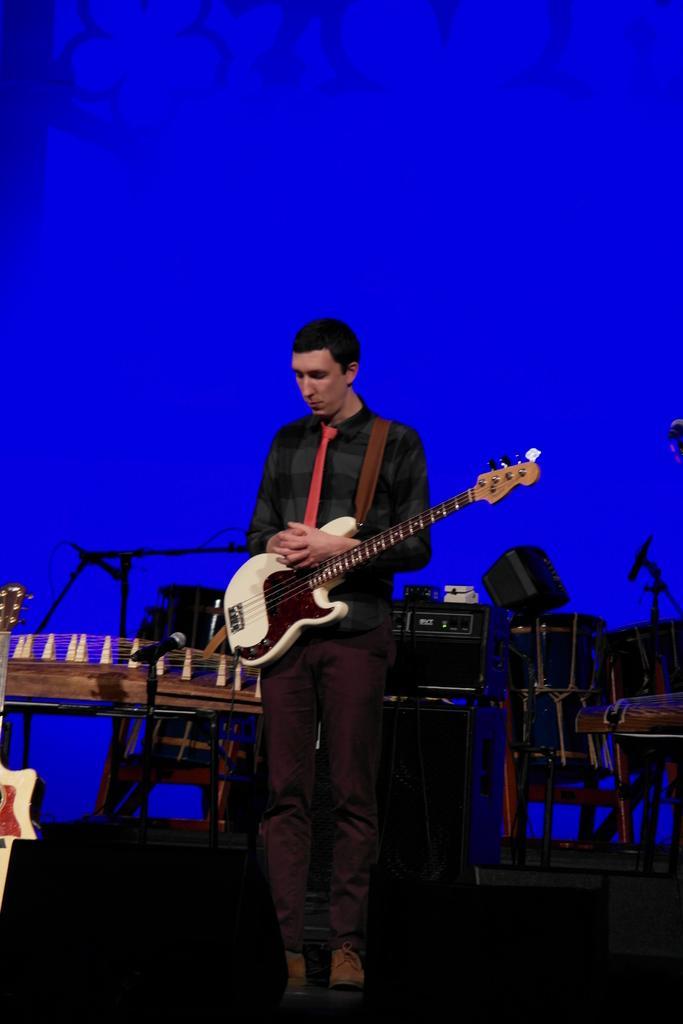Can you describe this image briefly? In this image there is a person standing with guitar. At the backside of him there are few musical instruments. There is a mile before this person. 